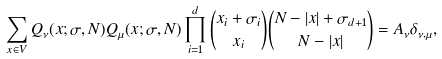<formula> <loc_0><loc_0><loc_500><loc_500>\sum _ { x \in V } Q _ { \nu } ( x ; \sigma , N ) Q _ { \mu } ( x ; \sigma , N ) \prod _ { i = 1 } ^ { d } \binom { x _ { i } + \sigma _ { i } } { x _ { i } } \binom { N - | x | + \sigma _ { d + 1 } } { N - | x | } = A _ { \nu } \delta _ { \nu , \mu } ,</formula> 